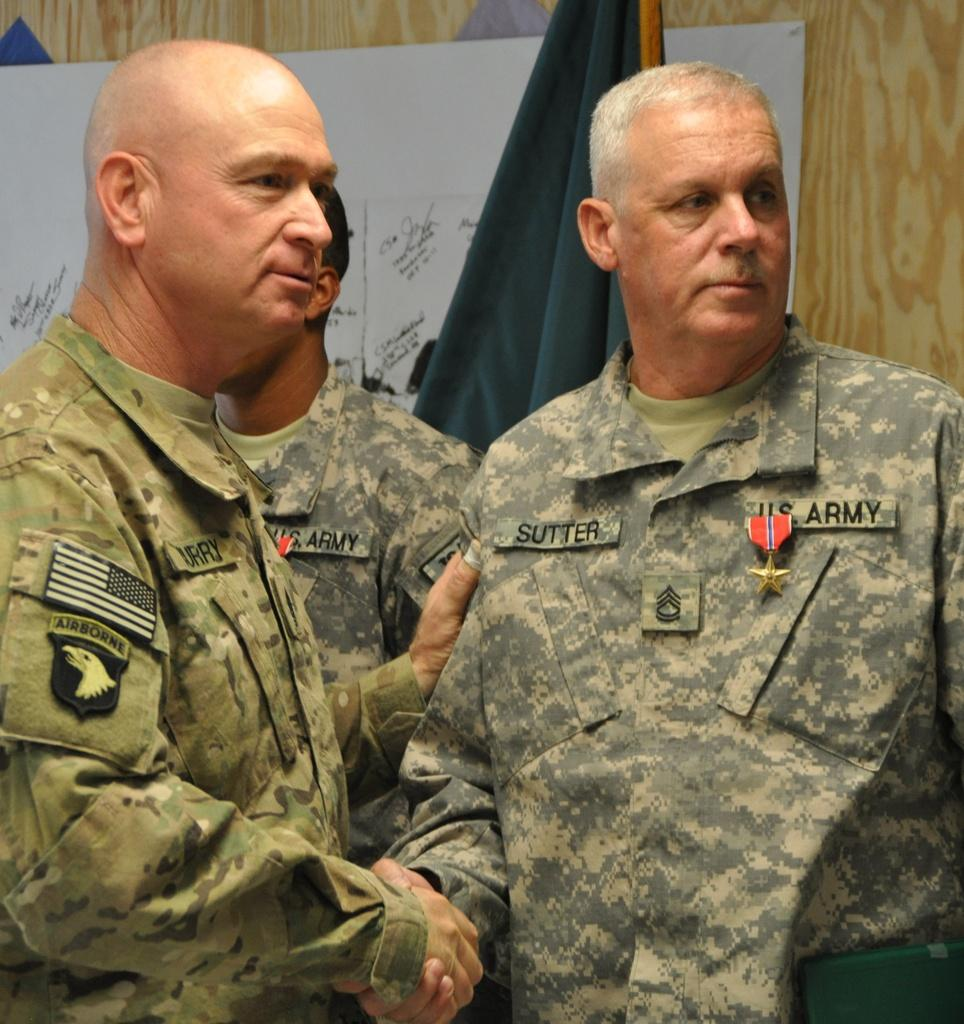How many people are in the image? There are three men standing in the image. What can be seen hanging from a pole in the image? There is a flag hanging from a pole in the image. What is visible in the background of the image? In the background, there are posters attached to a wall. Reasoning: Let' Let's think step by step in order to produce the conversation. We start by identifying the number of people in the image, which is three men. Then, we describe the flag hanging from a pole, which is another prominent feature in the image. Finally, we mention the posters on the wall in the background, providing additional context to the scene. Absurd Question/Answer: What type of list can be seen on the watch in the image? There is no watch or list present in the image. Can you describe the rock formation in the image? There is no rock formation visible in the image. 